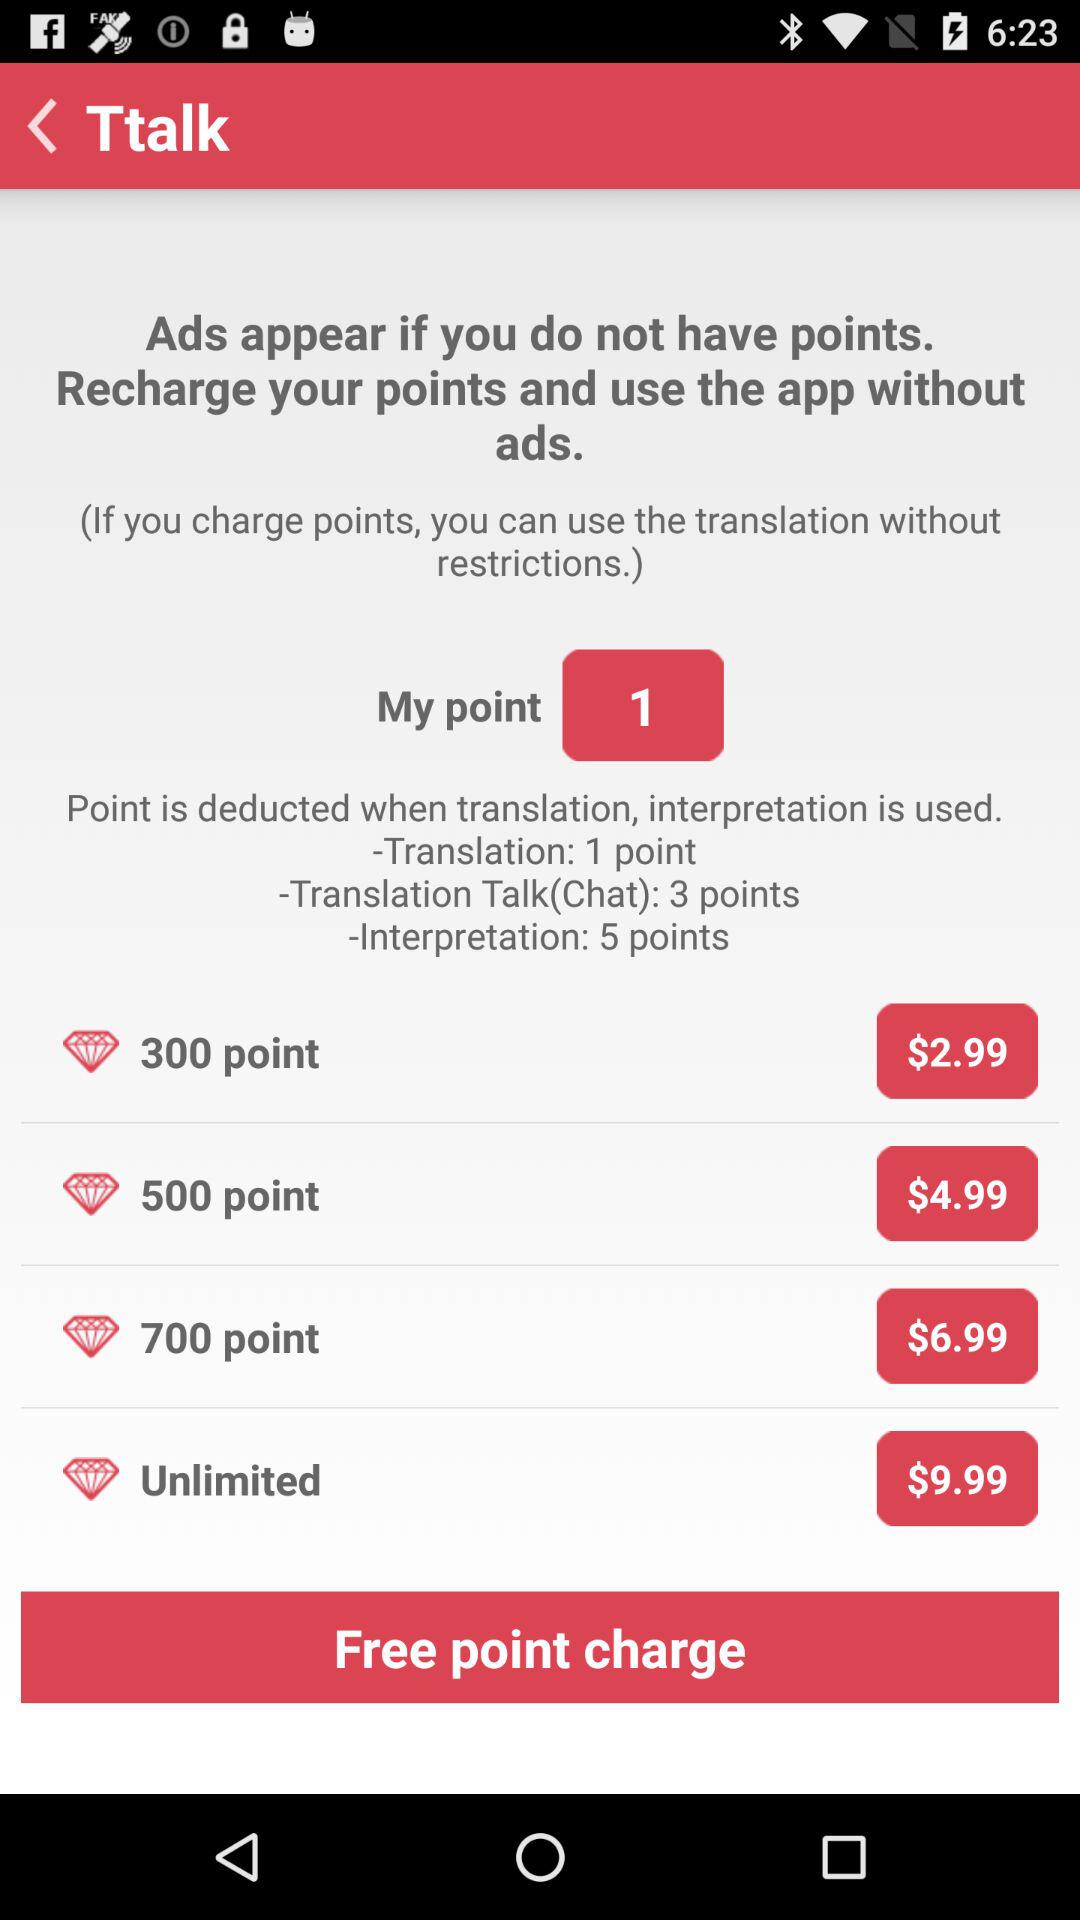What is the price of the "Unlimited" pack? The price of the "Unlimited" pack is $9.99. 